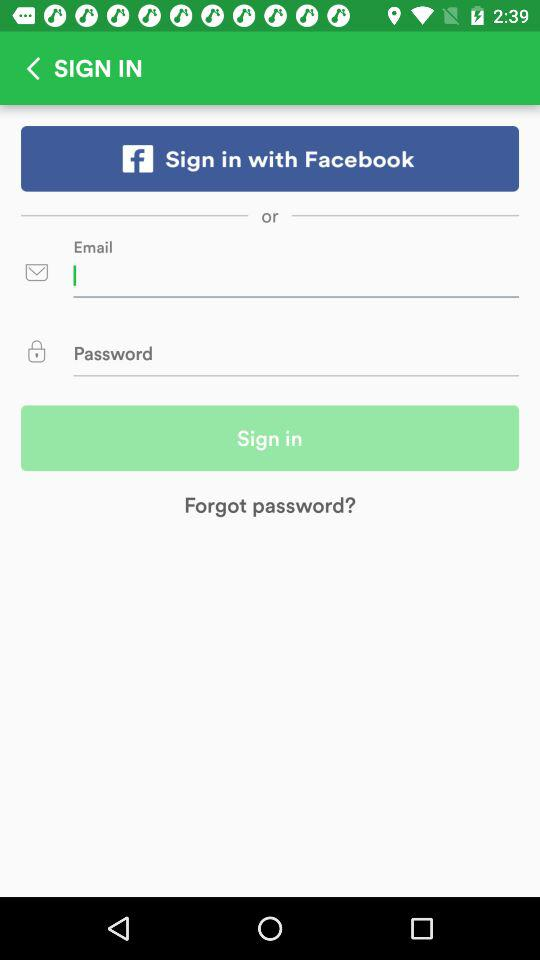How many more login options are there than social media login options?
Answer the question using a single word or phrase. 1 